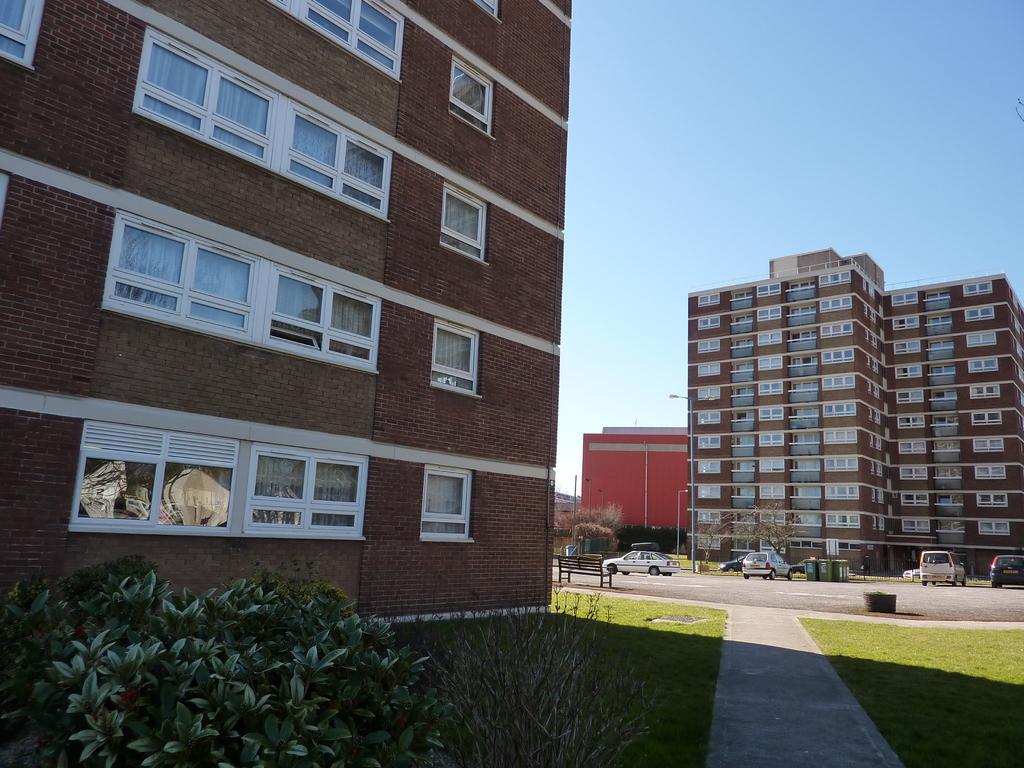Please provide a concise description of this image. We can see plants,grass,windows and building. Background we can see buildings,bench,vehicles,pole and sky. 